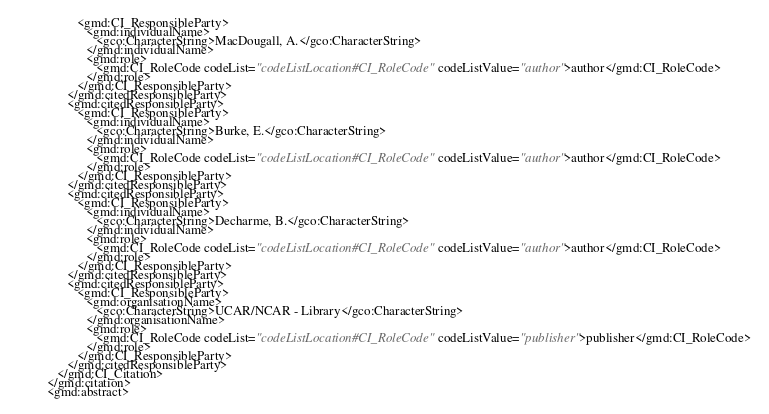<code> <loc_0><loc_0><loc_500><loc_500><_XML_>                  <gmd:CI_ResponsibleParty>
                     <gmd:individualName>
                        <gco:CharacterString>MacDougall, A.</gco:CharacterString>
                     </gmd:individualName>
                     <gmd:role>
                        <gmd:CI_RoleCode codeList="codeListLocation#CI_RoleCode" codeListValue="author">author</gmd:CI_RoleCode>
                     </gmd:role>
                  </gmd:CI_ResponsibleParty>
               </gmd:citedResponsibleParty>
               <gmd:citedResponsibleParty>
                  <gmd:CI_ResponsibleParty>
                     <gmd:individualName>
                        <gco:CharacterString>Burke, E.</gco:CharacterString>
                     </gmd:individualName>
                     <gmd:role>
                        <gmd:CI_RoleCode codeList="codeListLocation#CI_RoleCode" codeListValue="author">author</gmd:CI_RoleCode>
                     </gmd:role>
                  </gmd:CI_ResponsibleParty>
               </gmd:citedResponsibleParty>
               <gmd:citedResponsibleParty>
                  <gmd:CI_ResponsibleParty>
                     <gmd:individualName>
                        <gco:CharacterString>Decharme, B.</gco:CharacterString>
                     </gmd:individualName>
                     <gmd:role>
                        <gmd:CI_RoleCode codeList="codeListLocation#CI_RoleCode" codeListValue="author">author</gmd:CI_RoleCode>
                     </gmd:role>
                  </gmd:CI_ResponsibleParty>
               </gmd:citedResponsibleParty>
               <gmd:citedResponsibleParty>
                  <gmd:CI_ResponsibleParty>
                     <gmd:organisationName>
                        <gco:CharacterString>UCAR/NCAR - Library</gco:CharacterString>
                     </gmd:organisationName>
                     <gmd:role>
                        <gmd:CI_RoleCode codeList="codeListLocation#CI_RoleCode" codeListValue="publisher">publisher</gmd:CI_RoleCode>
                     </gmd:role>
                  </gmd:CI_ResponsibleParty>
               </gmd:citedResponsibleParty>
            </gmd:CI_Citation>
         </gmd:citation>
         <gmd:abstract></code> 